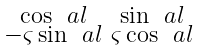<formula> <loc_0><loc_0><loc_500><loc_500>\begin{smallmatrix} \cos \ a l & \sin \ a l \\ - \varsigma \sin \ a l & \varsigma \cos \ a l \end{smallmatrix}</formula> 